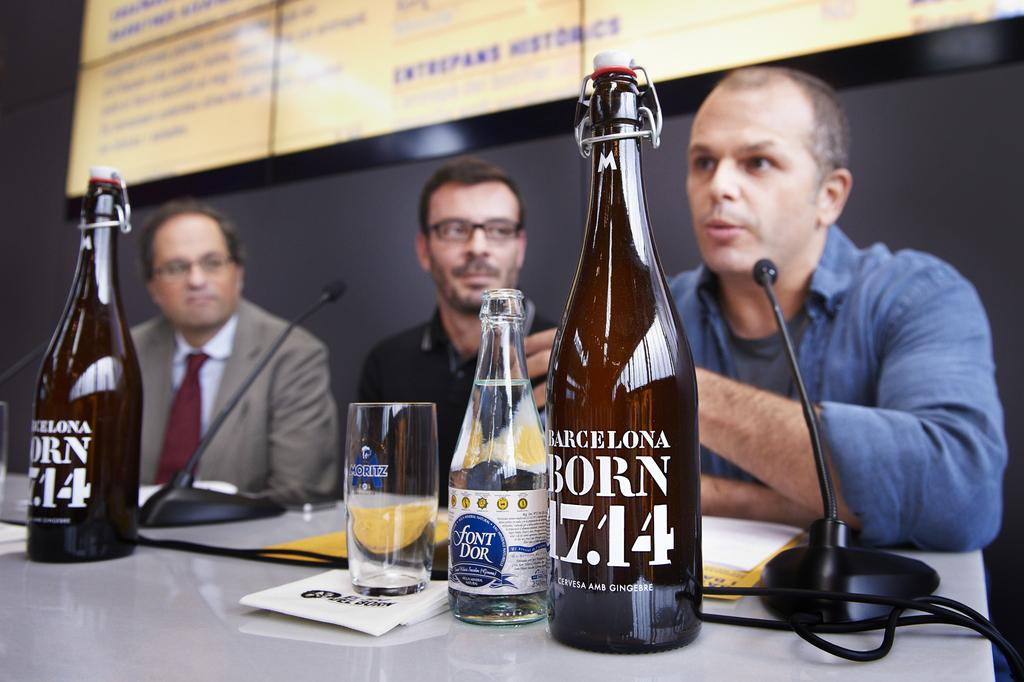<image>
Offer a succinct explanation of the picture presented. Three men speaking on a panel with bottles in front of them that read "Barcelona Born 17.14" and "Font Dor". 